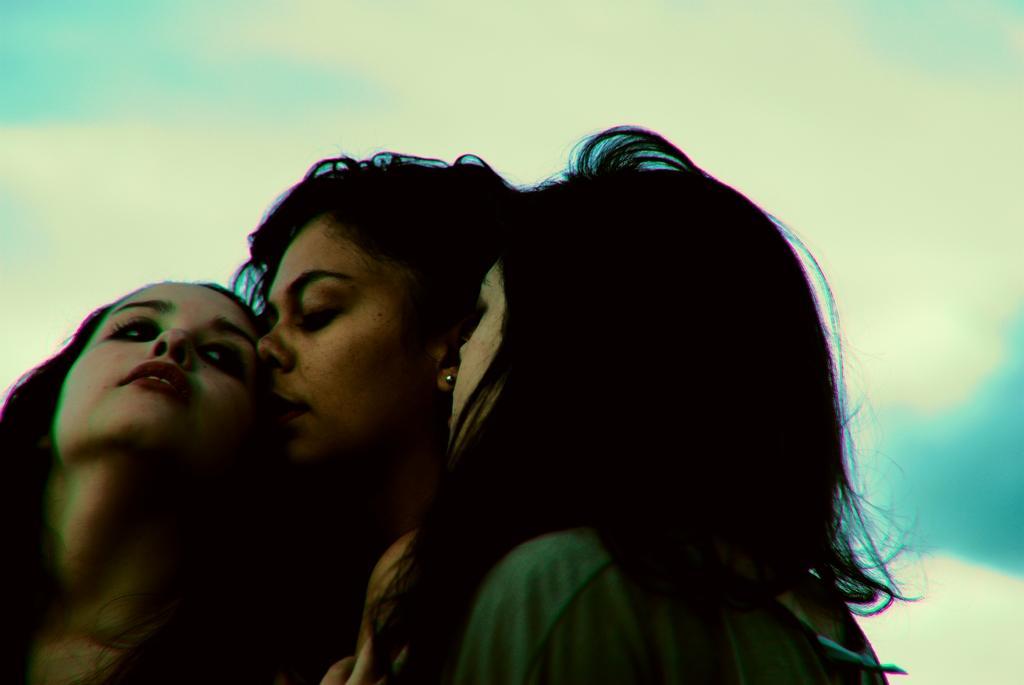In one or two sentences, can you explain what this image depicts? In this image we can see three girls. Background of the image blue color sky with some clouds are there. 